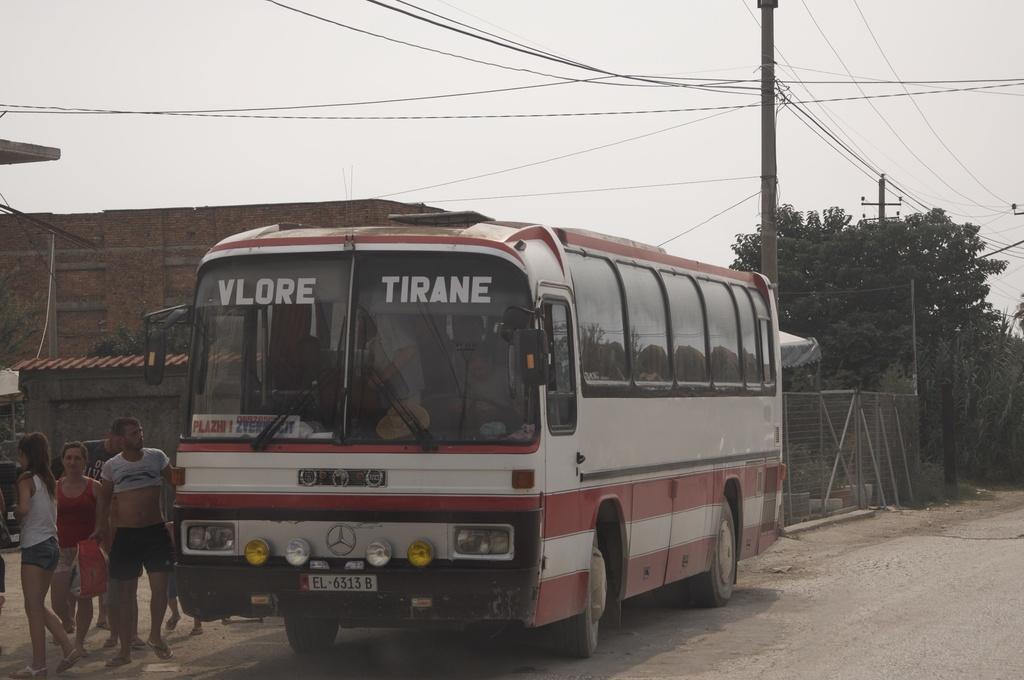Please provide a concise description of this image. In this picture I can see some persons who are sitting inside the bus. On the left I can see the group of persons who are standing near to the bus. Behind the bus I can see the electric poles, wires, fencing, tent, building, shed and trees. At the top I can see the sky. 